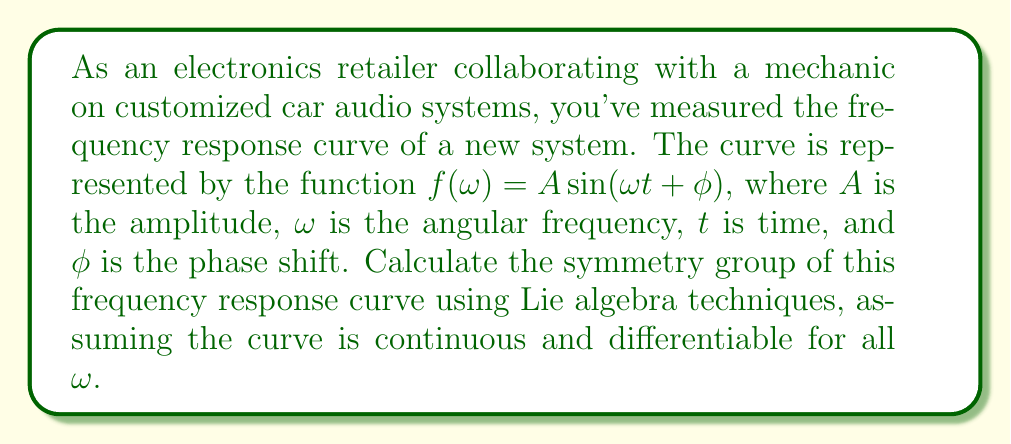Solve this math problem. To determine the symmetry group of the frequency response curve, we need to analyze the invariances of the function $f(\omega) = A \sin(\omega t + \phi)$ under various transformations. We'll use Lie algebra techniques to identify the infinitesimal generators of these symmetries.

1. Translation symmetry:
The function is invariant under translations in $\phi$. The infinitesimal generator for this symmetry is:
$$X_1 = \frac{\partial}{\partial \phi}$$

2. Scaling symmetry:
The amplitude $A$ can be scaled without changing the shape of the curve. The infinitesimal generator for this symmetry is:
$$X_2 = A \frac{\partial}{\partial A}$$

3. Time translation symmetry:
The function is invariant under translations in $t$. The infinitesimal generator for this symmetry is:
$$X_3 = \frac{\partial}{\partial t}$$

4. Frequency scaling symmetry:
There's a symmetry between $\omega$ and $t$, as scaling one is equivalent to scaling the other inversely. The infinitesimal generator for this symmetry is:
$$X_4 = \omega \frac{\partial}{\partial \omega} - t \frac{\partial}{\partial t}$$

Now, we need to check the commutation relations between these generators:

$$[X_1, X_2] = [X_1, X_3] = [X_1, X_4] = 0$$
$$[X_2, X_3] = [X_2, X_4] = 0$$
$$[X_3, X_4] = -X_3$$

These commutation relations reveal that $X_1$, $X_2$, and $X_3$ form an abelian subalgebra, while $X_4$ acts as a scaling operation on $X_3$.

The symmetry group can be identified as the semidirect product of the 3-dimensional abelian group (representing translations in $\phi$ and $t$, and scaling of $A$) with the 1-dimensional group of frequency scaling:

$$G = (\mathbb{R}^2 \times \mathbb{R}^+) \rtimes \mathbb{R}^+$$

where $\mathbb{R}^2$ represents translations in $\phi$ and $t$, the first $\mathbb{R}^+$ represents amplitude scaling, and the second $\mathbb{R}^+$ represents frequency scaling.
Answer: The symmetry group of the frequency response curve $f(\omega) = A \sin(\omega t + \phi)$ is $G = (\mathbb{R}^2 \times \mathbb{R}^+) \rtimes \mathbb{R}^+$, which is a 4-dimensional Lie group. 